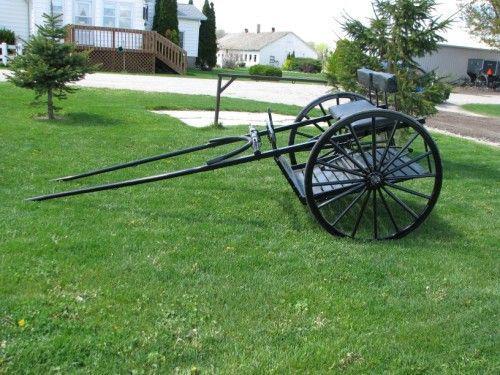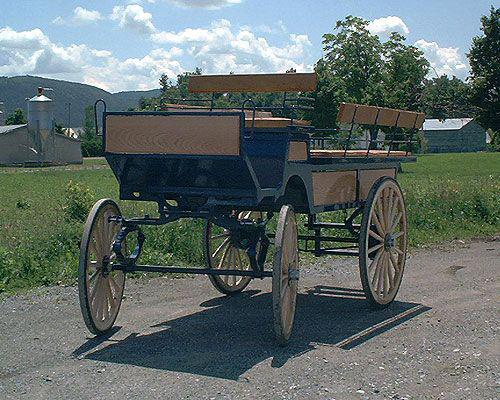The first image is the image on the left, the second image is the image on the right. Considering the images on both sides, is "There are humans riding in a carriage in the right image." valid? Answer yes or no. No. The first image is the image on the left, the second image is the image on the right. Considering the images on both sides, is "There is a white carriage led by a white horse in the left image." valid? Answer yes or no. No. 